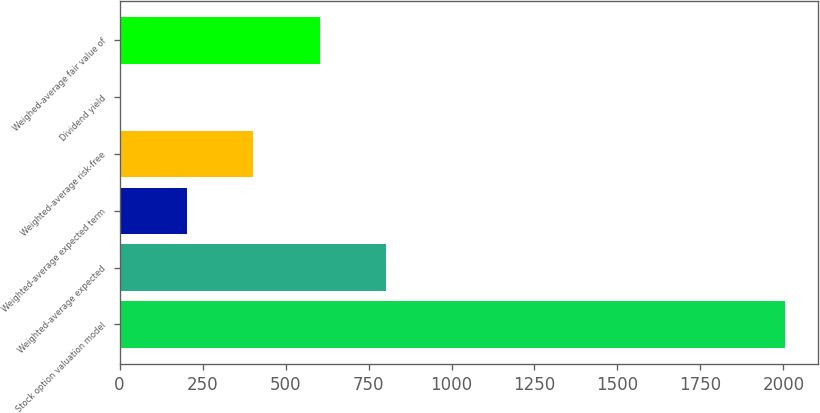<chart> <loc_0><loc_0><loc_500><loc_500><bar_chart><fcel>Stock option valuation model<fcel>Weighted-average expected<fcel>Weighted-average expected term<fcel>Weighted-average risk-free<fcel>Dividend yield<fcel>Weighed-average fair value of<nl><fcel>2005<fcel>803.44<fcel>202.66<fcel>402.92<fcel>2.4<fcel>603.18<nl></chart> 